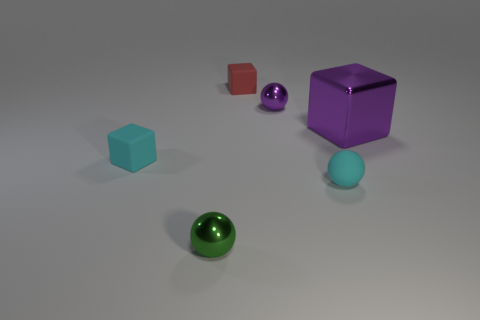Are there any other things that are the same size as the metallic block?
Offer a terse response. No. Are there more tiny cyan objects that are left of the small red matte cube than brown rubber cylinders?
Make the answer very short. Yes. There is a matte block in front of the large purple shiny cube; what number of tiny red rubber things are in front of it?
Your answer should be very brief. 0. What is the shape of the cyan matte thing on the right side of the tiny rubber object that is behind the big purple metallic block to the right of the tiny cyan ball?
Provide a succinct answer. Sphere. What size is the purple metallic block?
Your answer should be compact. Large. Are there any cubes made of the same material as the tiny green sphere?
Your response must be concise. Yes. What size is the other metallic object that is the same shape as the red object?
Make the answer very short. Large. Is the number of rubber blocks to the left of the red thing the same as the number of tiny green shiny balls?
Offer a terse response. Yes. There is a cyan thing to the left of the tiny green shiny thing; is it the same shape as the red rubber object?
Your response must be concise. Yes. What is the shape of the big shiny thing?
Make the answer very short. Cube. 